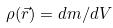<formula> <loc_0><loc_0><loc_500><loc_500>\rho ( { \vec { r } } ) = d m / d V</formula> 